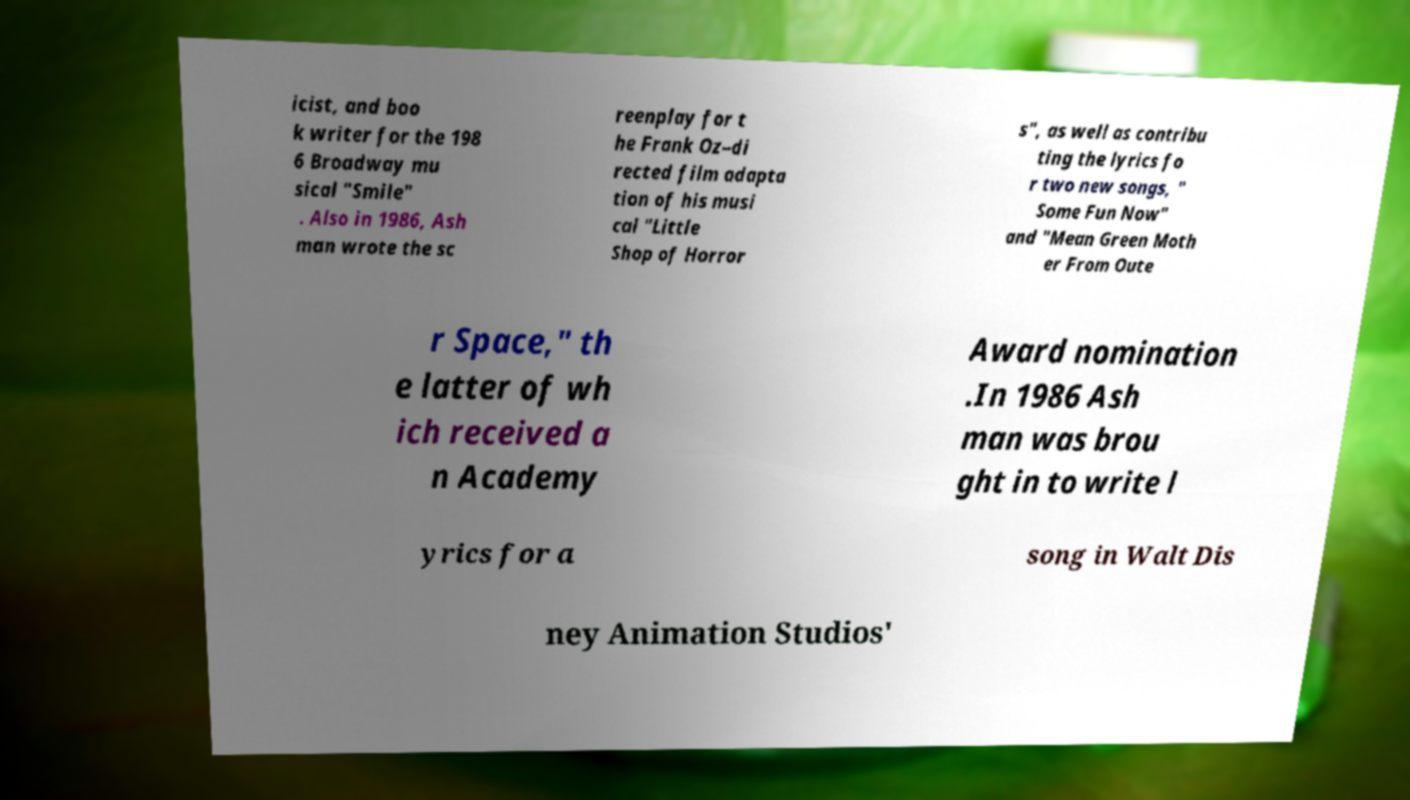Please identify and transcribe the text found in this image. icist, and boo k writer for the 198 6 Broadway mu sical "Smile" . Also in 1986, Ash man wrote the sc reenplay for t he Frank Oz–di rected film adapta tion of his musi cal "Little Shop of Horror s", as well as contribu ting the lyrics fo r two new songs, " Some Fun Now" and "Mean Green Moth er From Oute r Space," th e latter of wh ich received a n Academy Award nomination .In 1986 Ash man was brou ght in to write l yrics for a song in Walt Dis ney Animation Studios' 